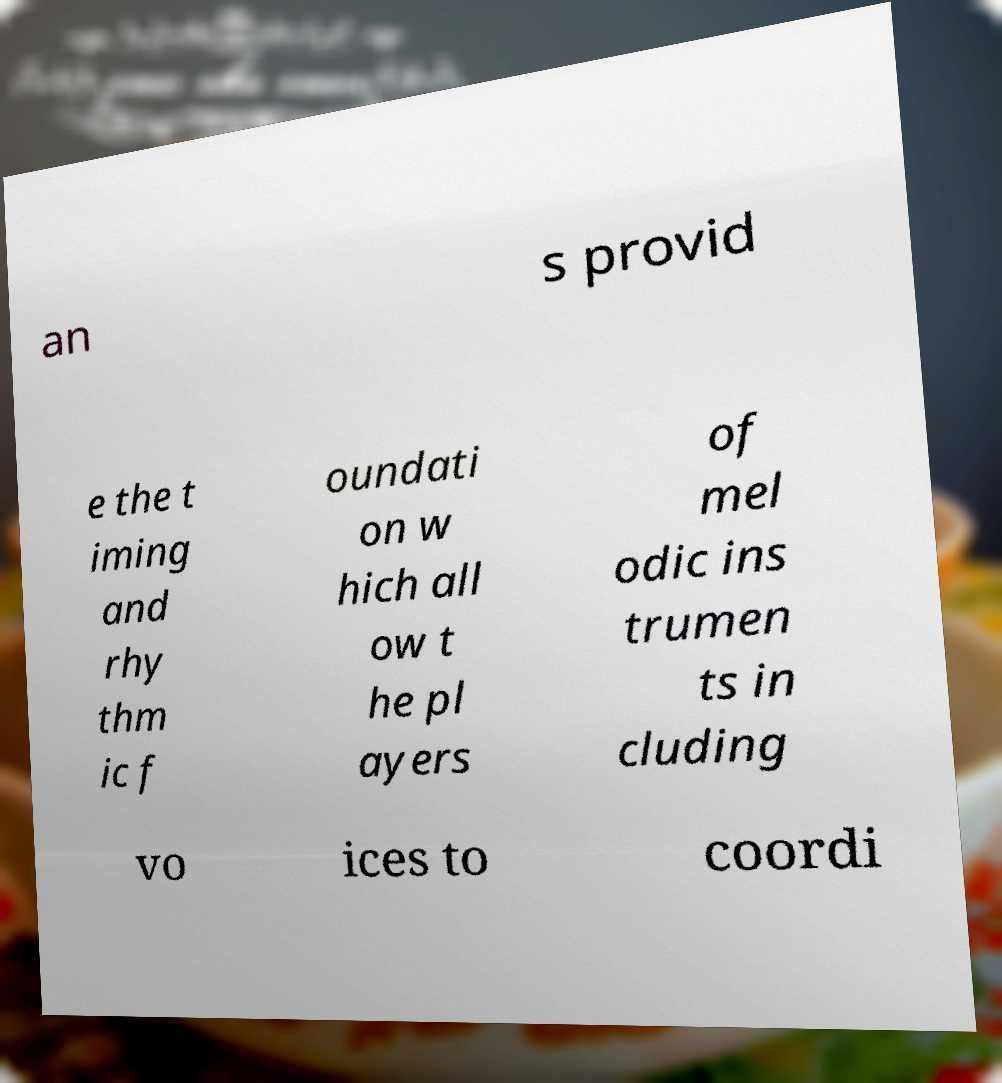I need the written content from this picture converted into text. Can you do that? an s provid e the t iming and rhy thm ic f oundati on w hich all ow t he pl ayers of mel odic ins trumen ts in cluding vo ices to coordi 